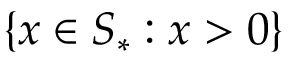Convert formula to latex. <formula><loc_0><loc_0><loc_500><loc_500>\{ x \in S _ { * } \colon x > 0 \}</formula> 